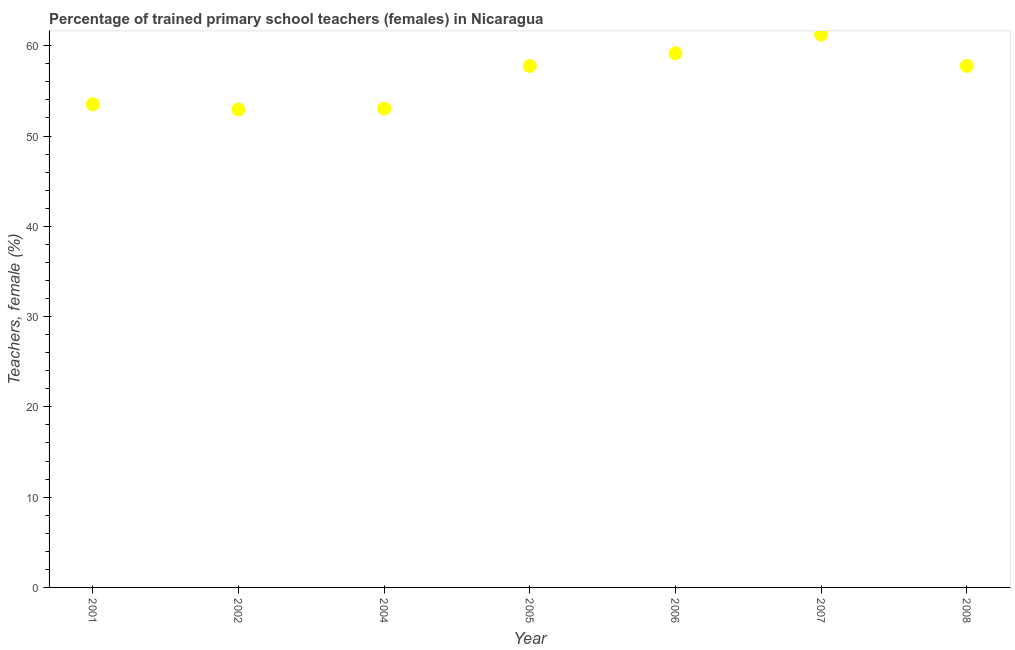What is the percentage of trained female teachers in 2006?
Offer a very short reply. 59.16. Across all years, what is the maximum percentage of trained female teachers?
Ensure brevity in your answer.  61.24. Across all years, what is the minimum percentage of trained female teachers?
Make the answer very short. 52.94. In which year was the percentage of trained female teachers maximum?
Your answer should be very brief. 2007. What is the sum of the percentage of trained female teachers?
Ensure brevity in your answer.  395.45. What is the difference between the percentage of trained female teachers in 2005 and 2007?
Keep it short and to the point. -3.48. What is the average percentage of trained female teachers per year?
Your answer should be very brief. 56.49. What is the median percentage of trained female teachers?
Your answer should be compact. 57.76. In how many years, is the percentage of trained female teachers greater than 6 %?
Make the answer very short. 7. Do a majority of the years between 2001 and 2004 (inclusive) have percentage of trained female teachers greater than 42 %?
Offer a very short reply. Yes. What is the ratio of the percentage of trained female teachers in 2005 to that in 2008?
Your response must be concise. 1. Is the percentage of trained female teachers in 2001 less than that in 2008?
Your answer should be compact. Yes. Is the difference between the percentage of trained female teachers in 2004 and 2008 greater than the difference between any two years?
Offer a very short reply. No. What is the difference between the highest and the second highest percentage of trained female teachers?
Your answer should be compact. 2.08. What is the difference between the highest and the lowest percentage of trained female teachers?
Ensure brevity in your answer.  8.29. Does the percentage of trained female teachers monotonically increase over the years?
Provide a succinct answer. No. How many dotlines are there?
Provide a succinct answer. 1. Does the graph contain any zero values?
Offer a terse response. No. What is the title of the graph?
Offer a very short reply. Percentage of trained primary school teachers (females) in Nicaragua. What is the label or title of the Y-axis?
Provide a short and direct response. Teachers, female (%). What is the Teachers, female (%) in 2001?
Offer a very short reply. 53.52. What is the Teachers, female (%) in 2002?
Ensure brevity in your answer.  52.94. What is the Teachers, female (%) in 2004?
Provide a short and direct response. 53.05. What is the Teachers, female (%) in 2005?
Offer a terse response. 57.76. What is the Teachers, female (%) in 2006?
Keep it short and to the point. 59.16. What is the Teachers, female (%) in 2007?
Make the answer very short. 61.24. What is the Teachers, female (%) in 2008?
Keep it short and to the point. 57.77. What is the difference between the Teachers, female (%) in 2001 and 2002?
Offer a terse response. 0.57. What is the difference between the Teachers, female (%) in 2001 and 2004?
Make the answer very short. 0.47. What is the difference between the Teachers, female (%) in 2001 and 2005?
Ensure brevity in your answer.  -4.24. What is the difference between the Teachers, female (%) in 2001 and 2006?
Your answer should be compact. -5.65. What is the difference between the Teachers, female (%) in 2001 and 2007?
Keep it short and to the point. -7.72. What is the difference between the Teachers, female (%) in 2001 and 2008?
Give a very brief answer. -4.25. What is the difference between the Teachers, female (%) in 2002 and 2004?
Offer a very short reply. -0.1. What is the difference between the Teachers, female (%) in 2002 and 2005?
Make the answer very short. -4.82. What is the difference between the Teachers, female (%) in 2002 and 2006?
Provide a short and direct response. -6.22. What is the difference between the Teachers, female (%) in 2002 and 2007?
Make the answer very short. -8.29. What is the difference between the Teachers, female (%) in 2002 and 2008?
Provide a short and direct response. -4.83. What is the difference between the Teachers, female (%) in 2004 and 2005?
Your answer should be very brief. -4.71. What is the difference between the Teachers, female (%) in 2004 and 2006?
Offer a very short reply. -6.12. What is the difference between the Teachers, female (%) in 2004 and 2007?
Give a very brief answer. -8.19. What is the difference between the Teachers, female (%) in 2004 and 2008?
Your answer should be compact. -4.73. What is the difference between the Teachers, female (%) in 2005 and 2006?
Offer a terse response. -1.4. What is the difference between the Teachers, female (%) in 2005 and 2007?
Offer a terse response. -3.48. What is the difference between the Teachers, female (%) in 2005 and 2008?
Make the answer very short. -0.01. What is the difference between the Teachers, female (%) in 2006 and 2007?
Your answer should be very brief. -2.08. What is the difference between the Teachers, female (%) in 2006 and 2008?
Make the answer very short. 1.39. What is the difference between the Teachers, female (%) in 2007 and 2008?
Offer a terse response. 3.47. What is the ratio of the Teachers, female (%) in 2001 to that in 2004?
Your answer should be compact. 1.01. What is the ratio of the Teachers, female (%) in 2001 to that in 2005?
Ensure brevity in your answer.  0.93. What is the ratio of the Teachers, female (%) in 2001 to that in 2006?
Provide a short and direct response. 0.91. What is the ratio of the Teachers, female (%) in 2001 to that in 2007?
Provide a short and direct response. 0.87. What is the ratio of the Teachers, female (%) in 2001 to that in 2008?
Provide a succinct answer. 0.93. What is the ratio of the Teachers, female (%) in 2002 to that in 2004?
Provide a short and direct response. 1. What is the ratio of the Teachers, female (%) in 2002 to that in 2005?
Offer a terse response. 0.92. What is the ratio of the Teachers, female (%) in 2002 to that in 2006?
Keep it short and to the point. 0.9. What is the ratio of the Teachers, female (%) in 2002 to that in 2007?
Give a very brief answer. 0.86. What is the ratio of the Teachers, female (%) in 2002 to that in 2008?
Give a very brief answer. 0.92. What is the ratio of the Teachers, female (%) in 2004 to that in 2005?
Your answer should be very brief. 0.92. What is the ratio of the Teachers, female (%) in 2004 to that in 2006?
Offer a terse response. 0.9. What is the ratio of the Teachers, female (%) in 2004 to that in 2007?
Provide a short and direct response. 0.87. What is the ratio of the Teachers, female (%) in 2004 to that in 2008?
Make the answer very short. 0.92. What is the ratio of the Teachers, female (%) in 2005 to that in 2006?
Offer a terse response. 0.98. What is the ratio of the Teachers, female (%) in 2005 to that in 2007?
Give a very brief answer. 0.94. What is the ratio of the Teachers, female (%) in 2006 to that in 2008?
Ensure brevity in your answer.  1.02. What is the ratio of the Teachers, female (%) in 2007 to that in 2008?
Provide a short and direct response. 1.06. 